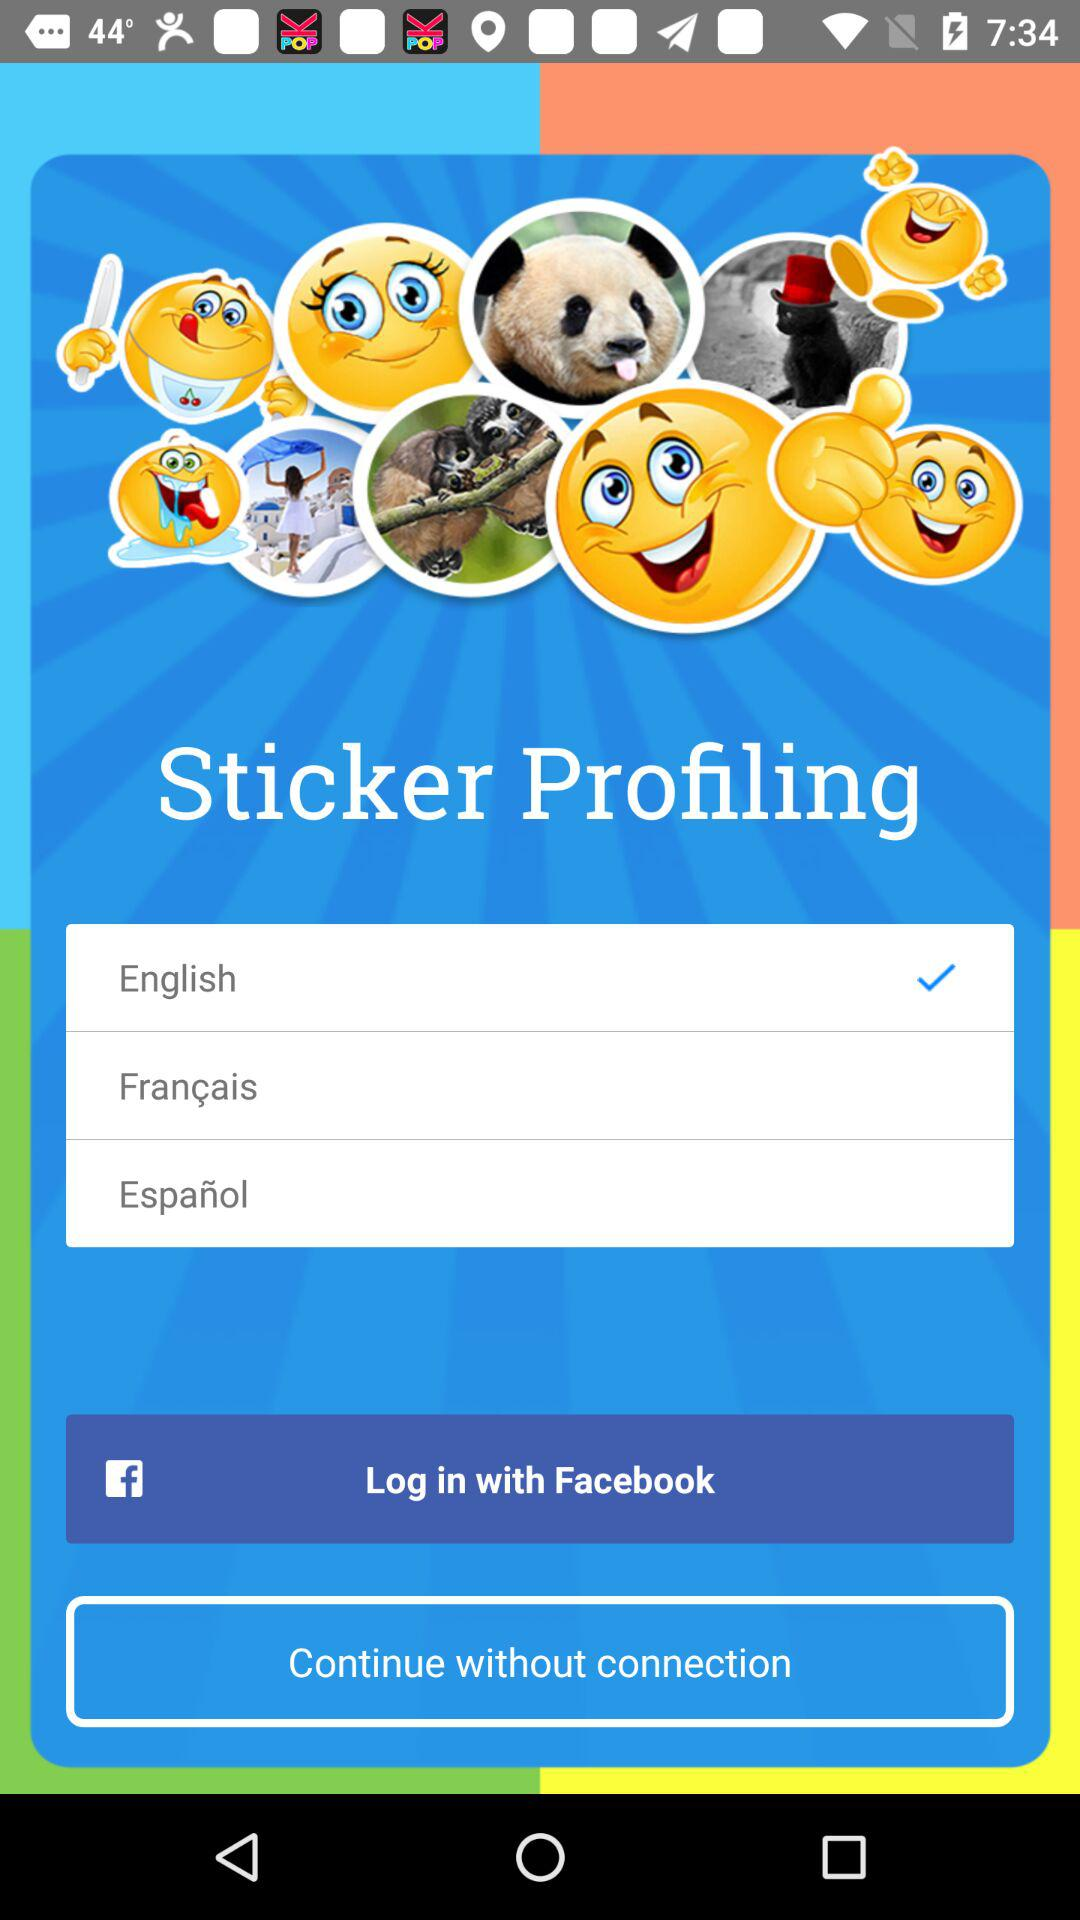How many languages are available for selection?
Answer the question using a single word or phrase. 3 